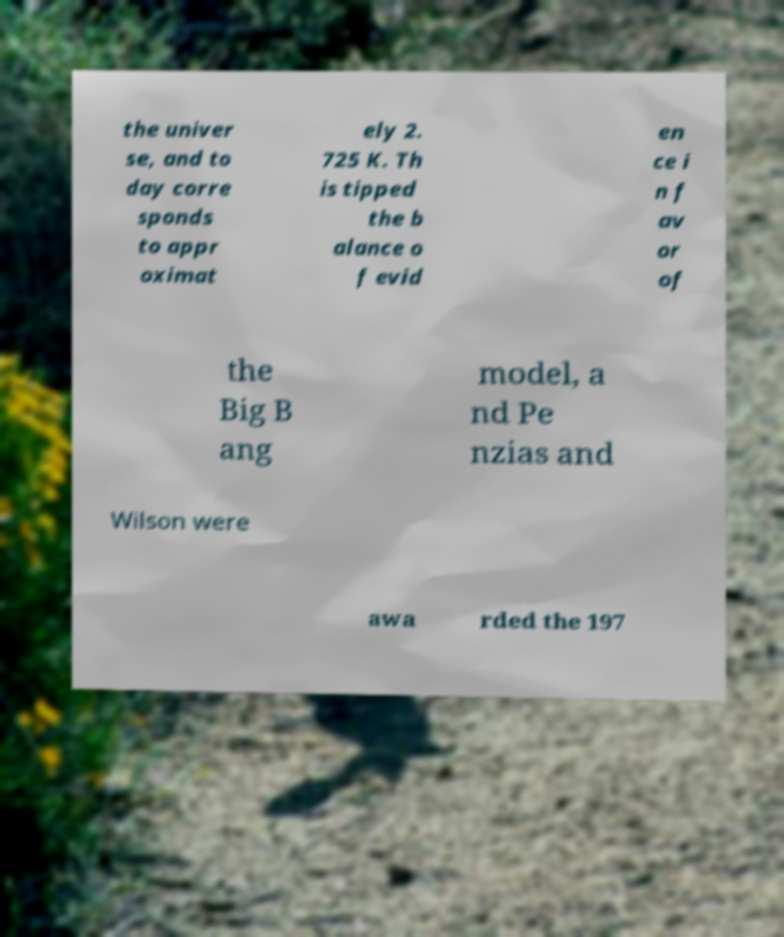I need the written content from this picture converted into text. Can you do that? the univer se, and to day corre sponds to appr oximat ely 2. 725 K. Th is tipped the b alance o f evid en ce i n f av or of the Big B ang model, a nd Pe nzias and Wilson were awa rded the 197 